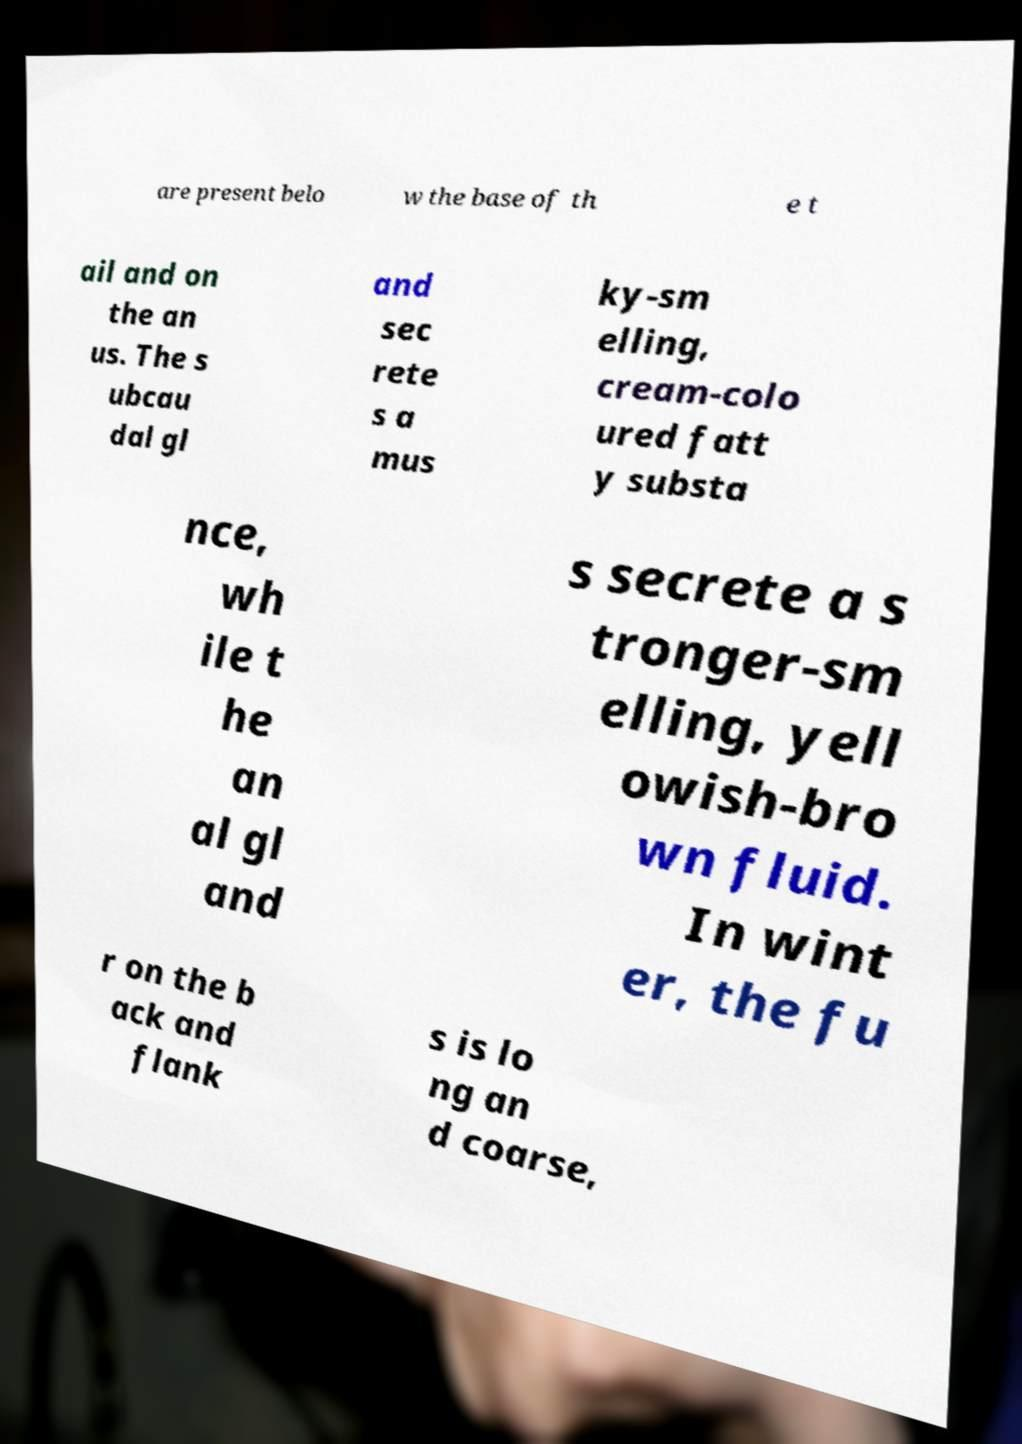For documentation purposes, I need the text within this image transcribed. Could you provide that? are present belo w the base of th e t ail and on the an us. The s ubcau dal gl and sec rete s a mus ky-sm elling, cream-colo ured fatt y substa nce, wh ile t he an al gl and s secrete a s tronger-sm elling, yell owish-bro wn fluid. In wint er, the fu r on the b ack and flank s is lo ng an d coarse, 